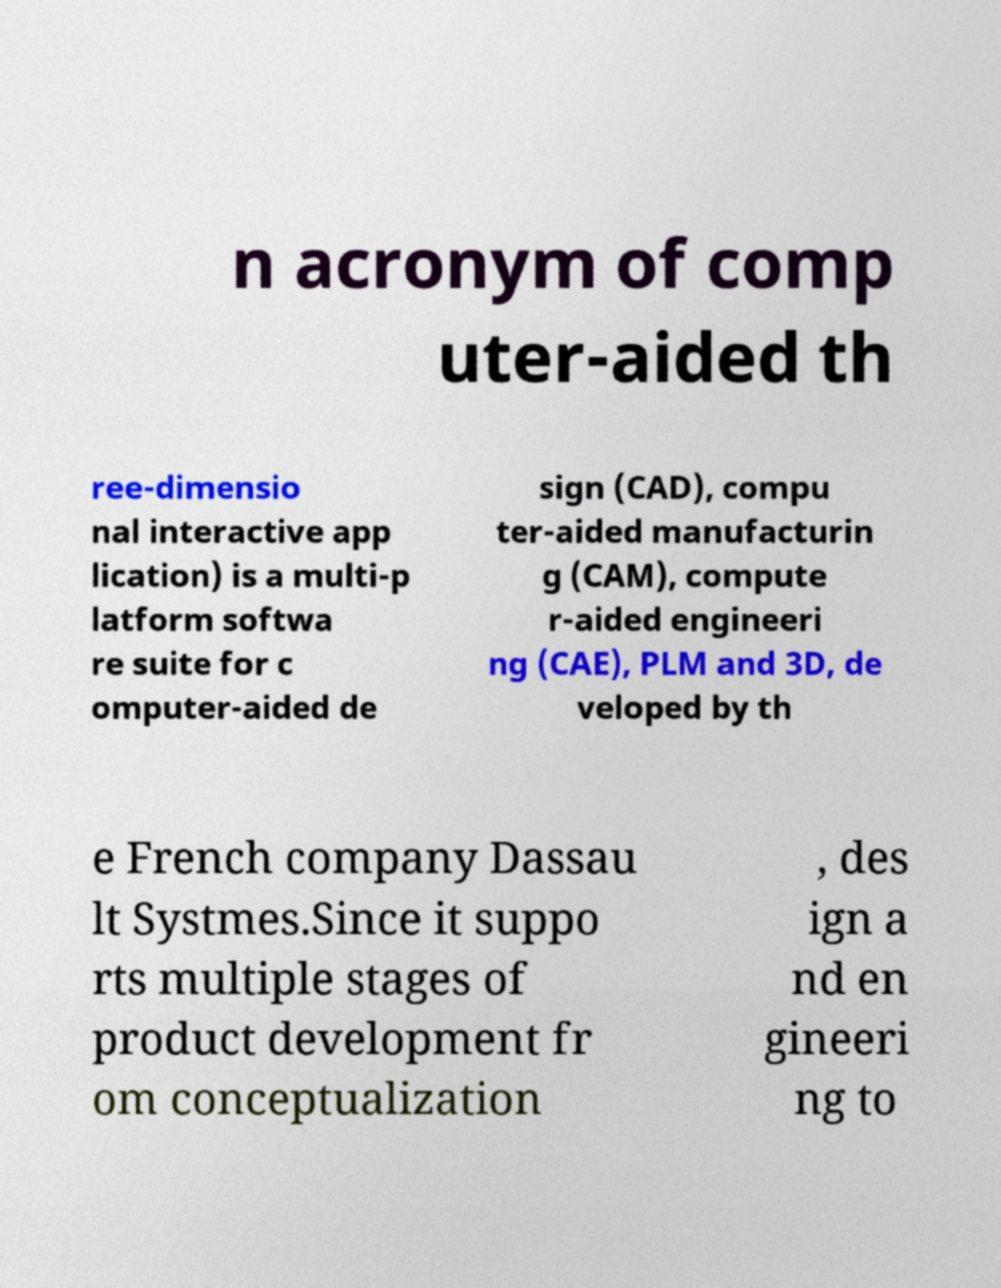For documentation purposes, I need the text within this image transcribed. Could you provide that? n acronym of comp uter-aided th ree-dimensio nal interactive app lication) is a multi-p latform softwa re suite for c omputer-aided de sign (CAD), compu ter-aided manufacturin g (CAM), compute r-aided engineeri ng (CAE), PLM and 3D, de veloped by th e French company Dassau lt Systmes.Since it suppo rts multiple stages of product development fr om conceptualization , des ign a nd en gineeri ng to 